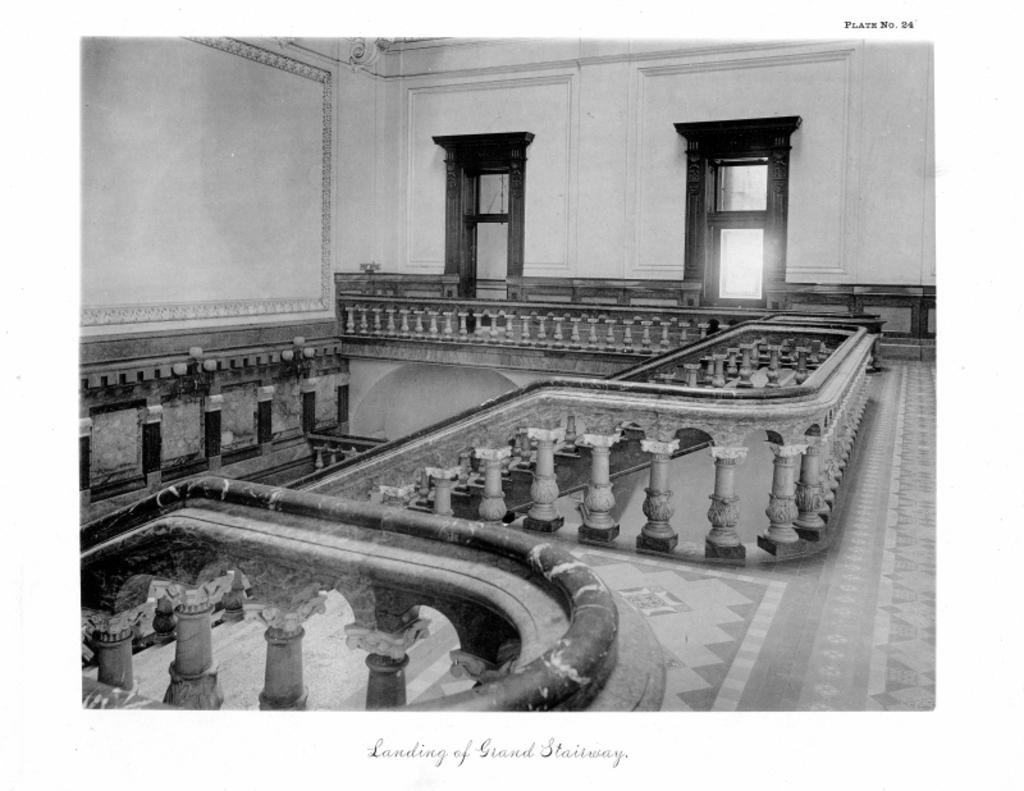What part of a building is shown in the image? The image shows the inner part of a building. What architectural feature can be seen in the image? There is a railing visible in the image. What are some other features of the building shown in the image? There are doors, walls, and stairs visible in the image. Where is the rabbit hiding in the image? There is no rabbit present in the image. What time is displayed on the clock in the image? There is no clock present in the image. 